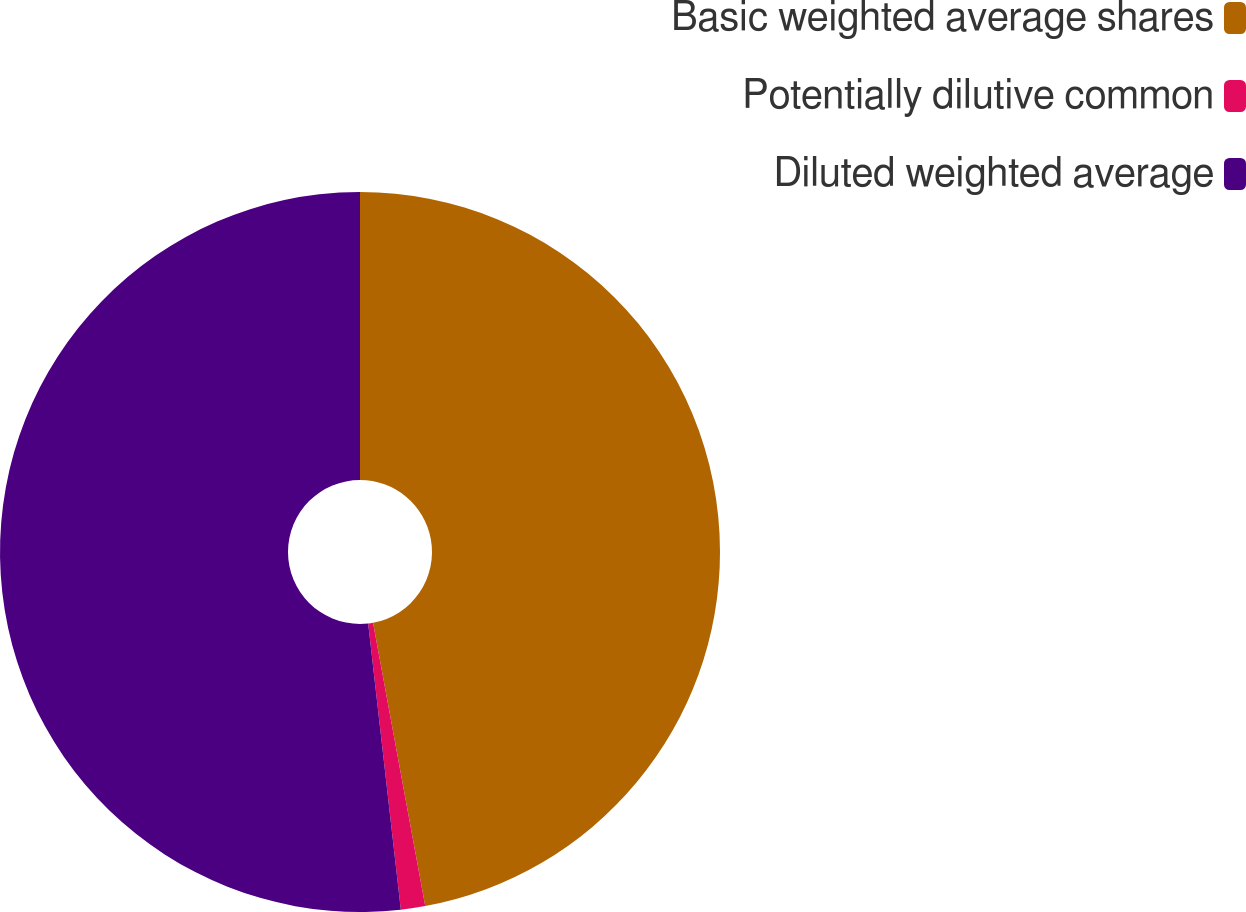Convert chart. <chart><loc_0><loc_0><loc_500><loc_500><pie_chart><fcel>Basic weighted average shares<fcel>Potentially dilutive common<fcel>Diluted weighted average<nl><fcel>47.1%<fcel>1.09%<fcel>51.81%<nl></chart> 